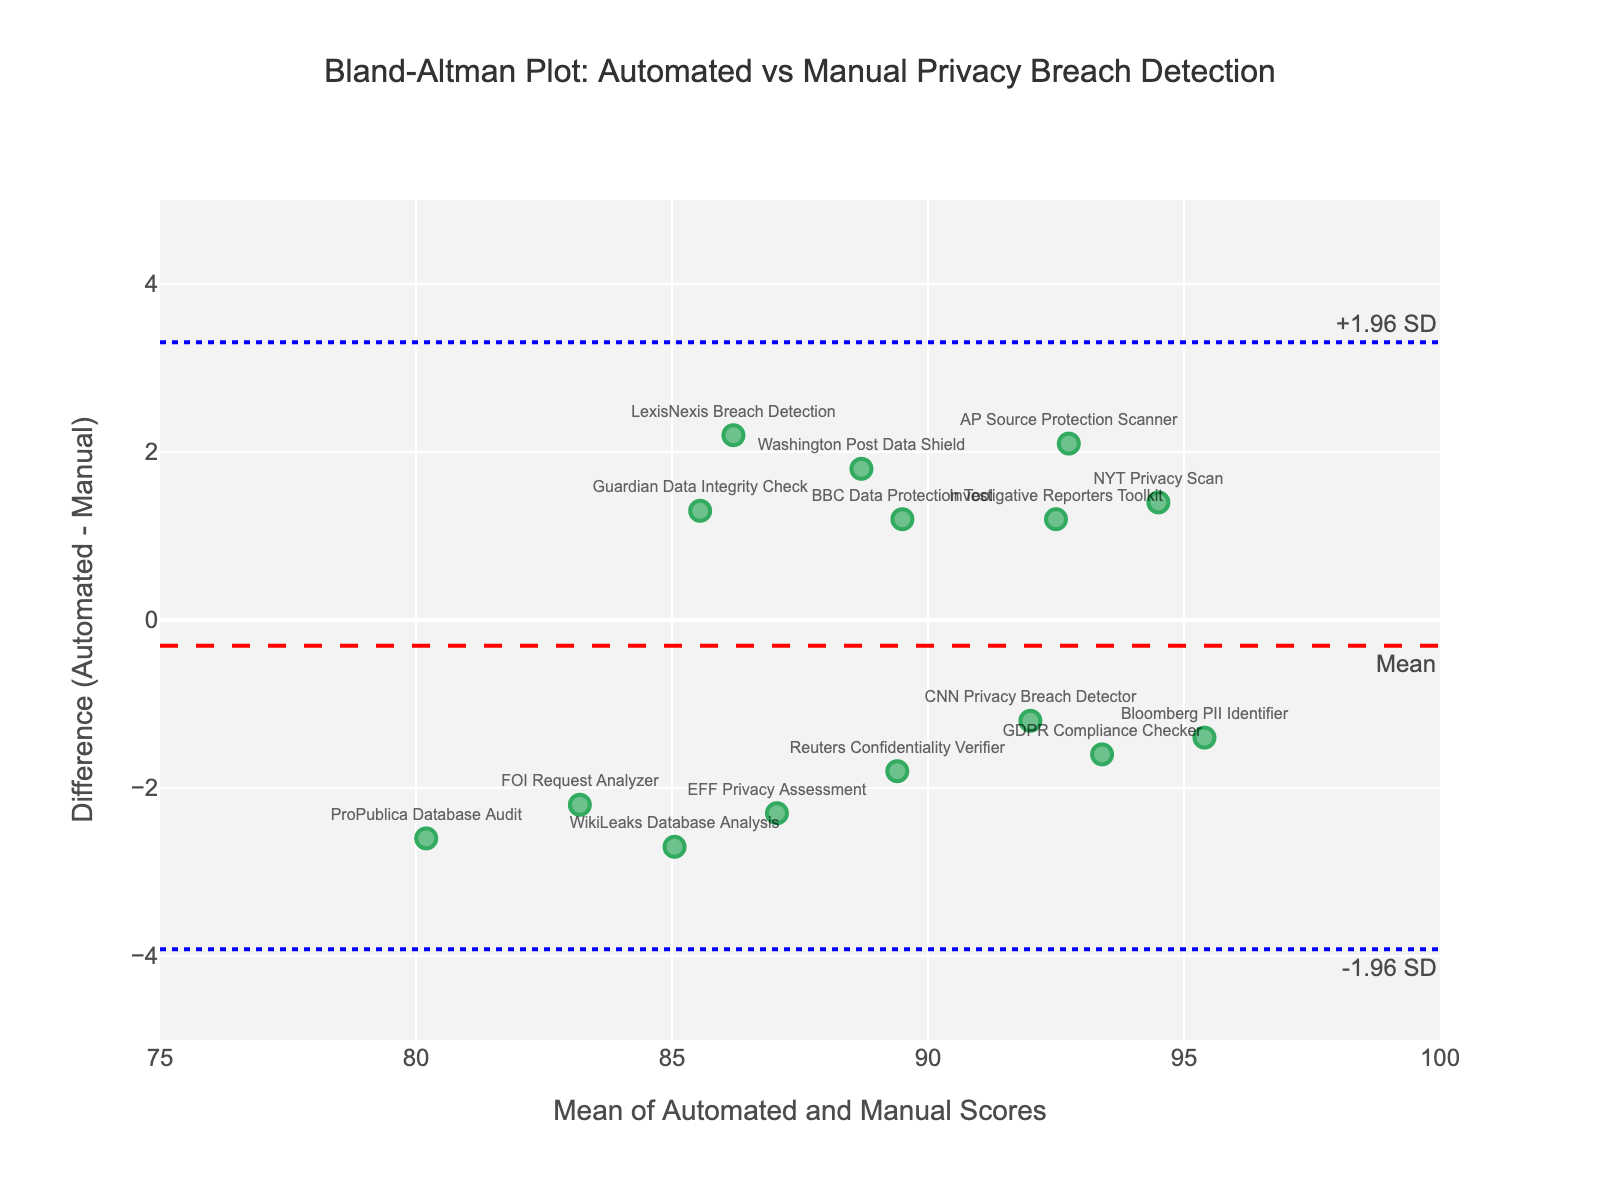What is the title of the plot? The title is usually displayed at the top center of the plot. The title reads "Bland-Altman Plot: Automated vs Manual Privacy Breach Detection."
Answer: Bland-Altman Plot: Automated vs Manual Privacy Breach Detection What is the y-axis label, and what does it represent? The y-axis label indicates the measurement that's being plotted there. The y-axis is labeled "Difference (Automated - Manual)," representing the difference between the automated and manual scores for detecting privacy breaches.
Answer: Difference (Automated - Manual) How many data points are plotted in the figure? Each point represents a method for detecting privacy breaches, including methods from LexisNexis to EFF Privacy Assessment. Count the markers on the plot to get the total number. There are 15 data points.
Answer: 15 What do the dashed and dotted horizontal lines represent? The dashed red line represents the mean difference between automated and manual scores, and the dotted blue lines represent the limits of agreement, which are 1.96 times the standard deviation above and below the mean difference.
Answer: The dashed red line is the mean difference; the dotted blue lines are the limits of agreement Which method shows the largest positive difference between automated and manual scores? Look for the point with the highest positive value on the y-axis, which signifies the largest positive difference. Here, "EFF Privacy Assessment" has the largest positive difference of approximately +2.3.
Answer: EFF Privacy Assessment What are the upper and lower limits of agreement? The upper limit of agreement is the mean difference plus 1.96 times the standard deviation, and the lower limit is the mean difference minus 1.96 times the standard deviation. By checking the plot, the upper limit is about +2.96 and the lower limit is about -2.96.
Answer: +2.96 and -2.96 Which methods indicate a manual score higher than the automated score? Points below the y=0 line have negative differences, meaning the manual score is higher. Examples include "GDPR Compliance Checker" and "ProPublica Database Audit."
Answer: GDPR Compliance Checker, ProPublica Database Audit What is the mean difference, and where is it located on the plot? The mean difference is represented by the horizontal dashed red line. It is the average of all differences between automated and manual scores, located at approximately 0 on the y-axis.
Answer: 0 Is there a visible trend or pattern in the plot? In a Bland-Altman plot, look for clustering or patterns. Here, the differences appear randomly scattered around the mean difference (close to 0), indicating no systematic bias.
Answer: No visible trend How well do the automated and manual methods agree on average, considering the mean difference and limits of agreement? The mean difference near 0 and the relatively narrow limits of agreement (approximately +2.96 and -2.96) indicate generally good agreement, though some discrepancies exist within the limits.
Answer: Good agreement with some discrepancies within limits 